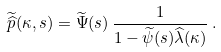Convert formula to latex. <formula><loc_0><loc_0><loc_500><loc_500>\widetilde { \widehat { p } } ( \kappa , s ) = \widetilde { \Psi } ( s ) \, \frac { 1 } { 1 - \widetilde { \psi } ( s ) \widehat { \lambda } ( \kappa ) } \, .</formula> 